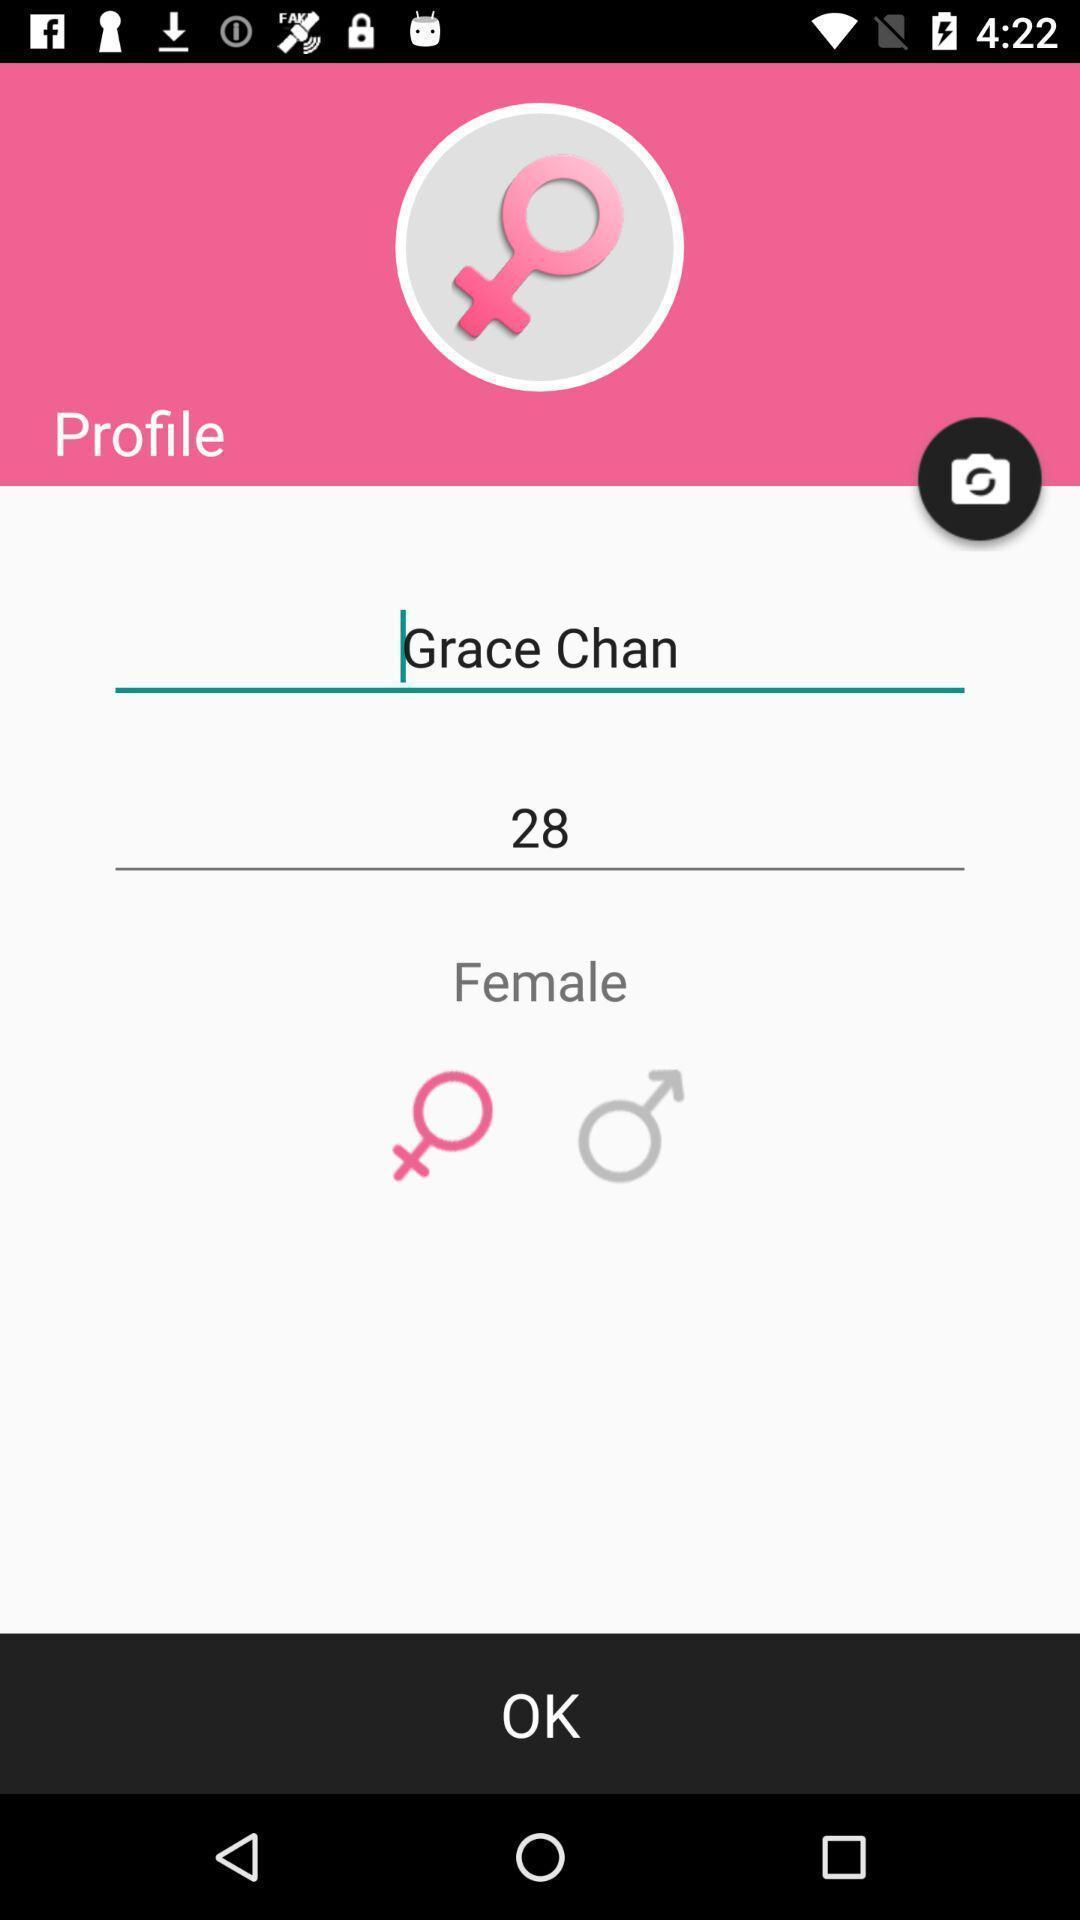What details can you identify in this image? Profile page of women for an app. 